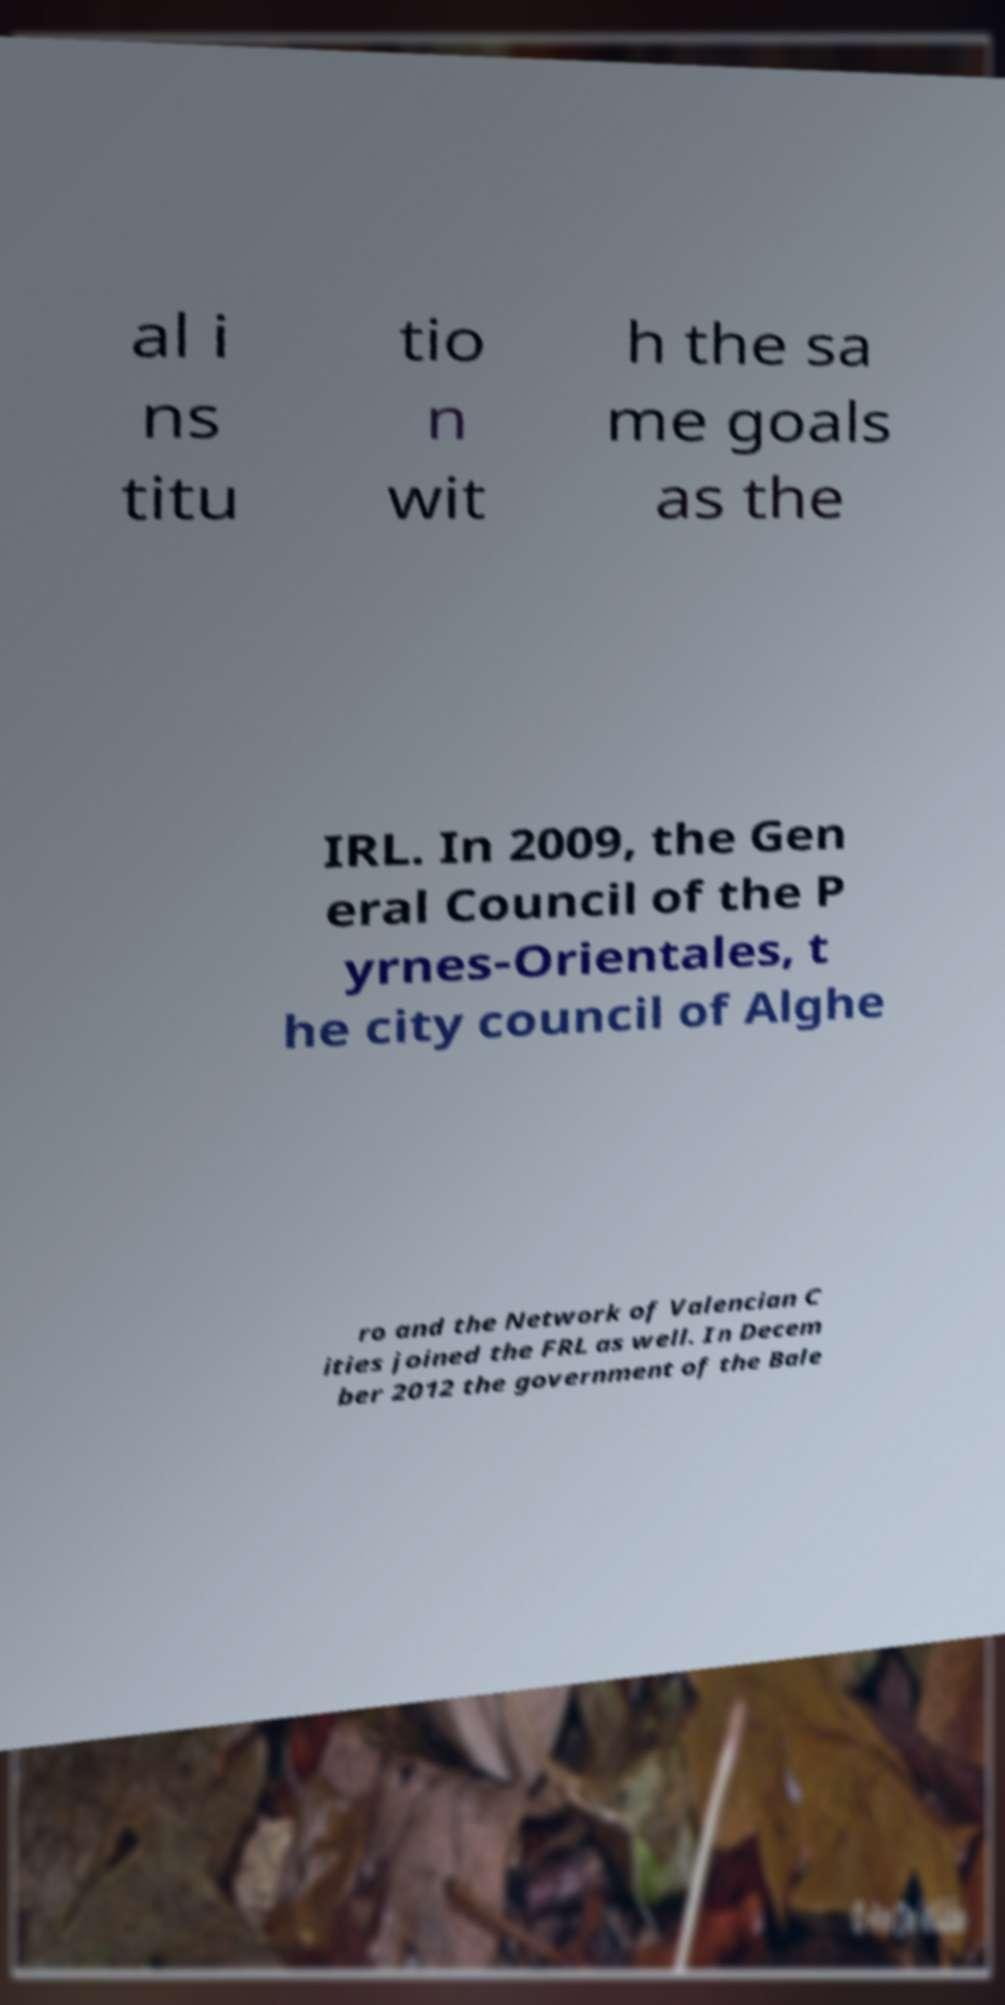For documentation purposes, I need the text within this image transcribed. Could you provide that? al i ns titu tio n wit h the sa me goals as the IRL. In 2009, the Gen eral Council of the P yrnes-Orientales, t he city council of Alghe ro and the Network of Valencian C ities joined the FRL as well. In Decem ber 2012 the government of the Bale 